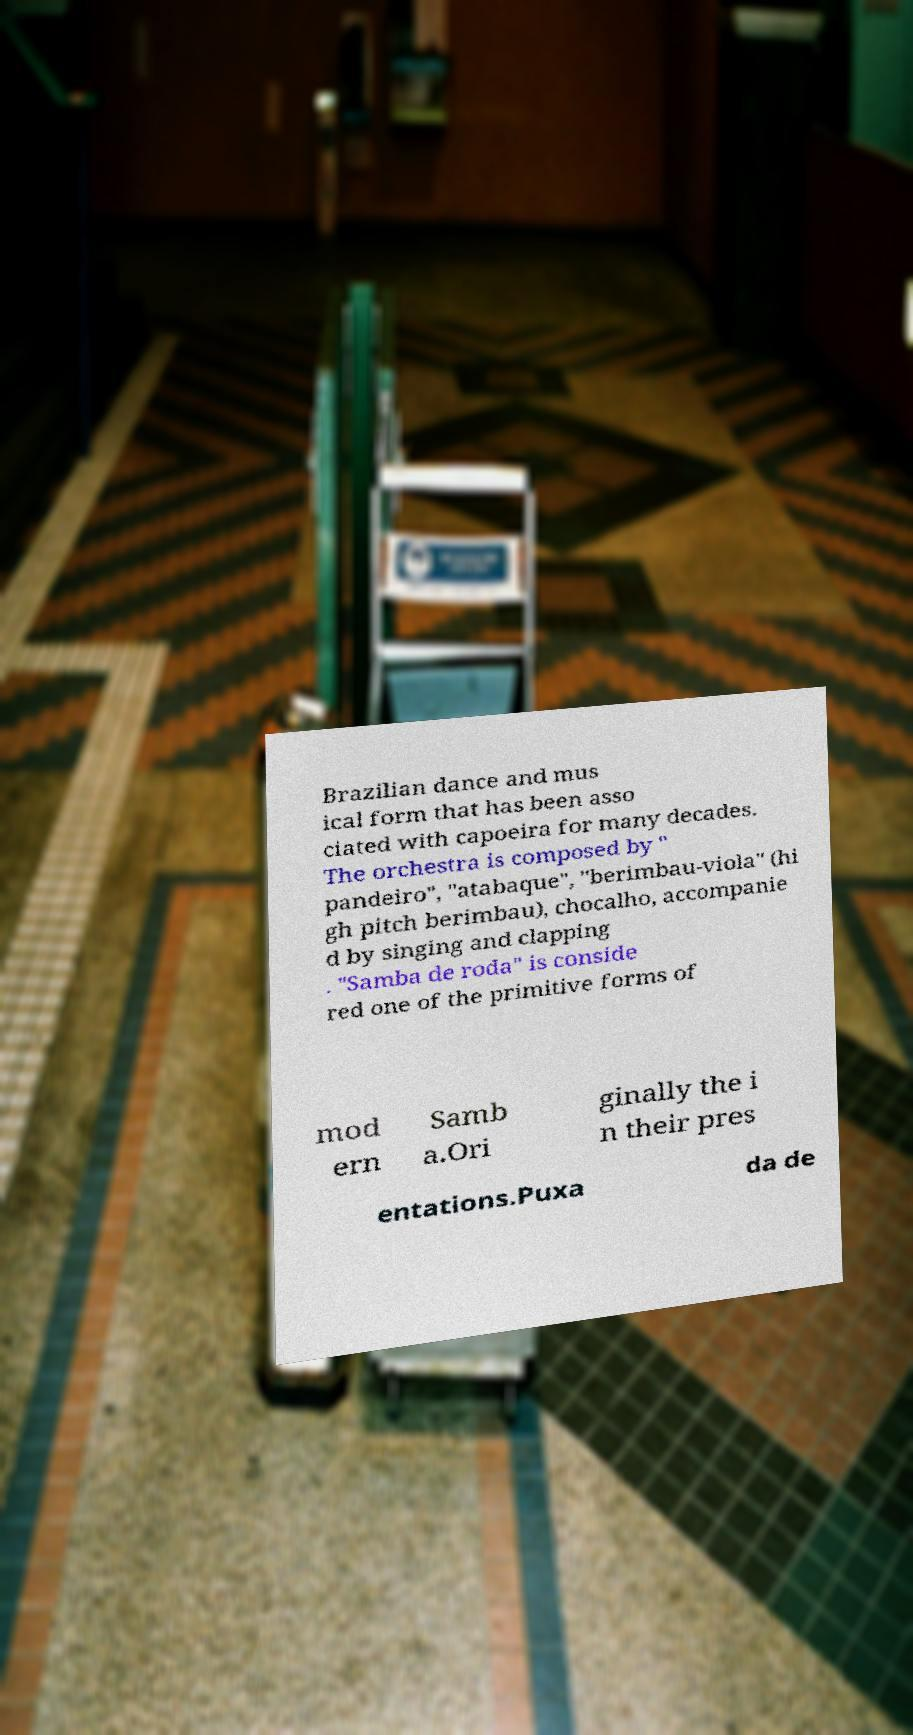Could you extract and type out the text from this image? Brazilian dance and mus ical form that has been asso ciated with capoeira for many decades. The orchestra is composed by " pandeiro", "atabaque", "berimbau-viola" (hi gh pitch berimbau), chocalho, accompanie d by singing and clapping . "Samba de roda" is conside red one of the primitive forms of mod ern Samb a.Ori ginally the i n their pres entations.Puxa da de 